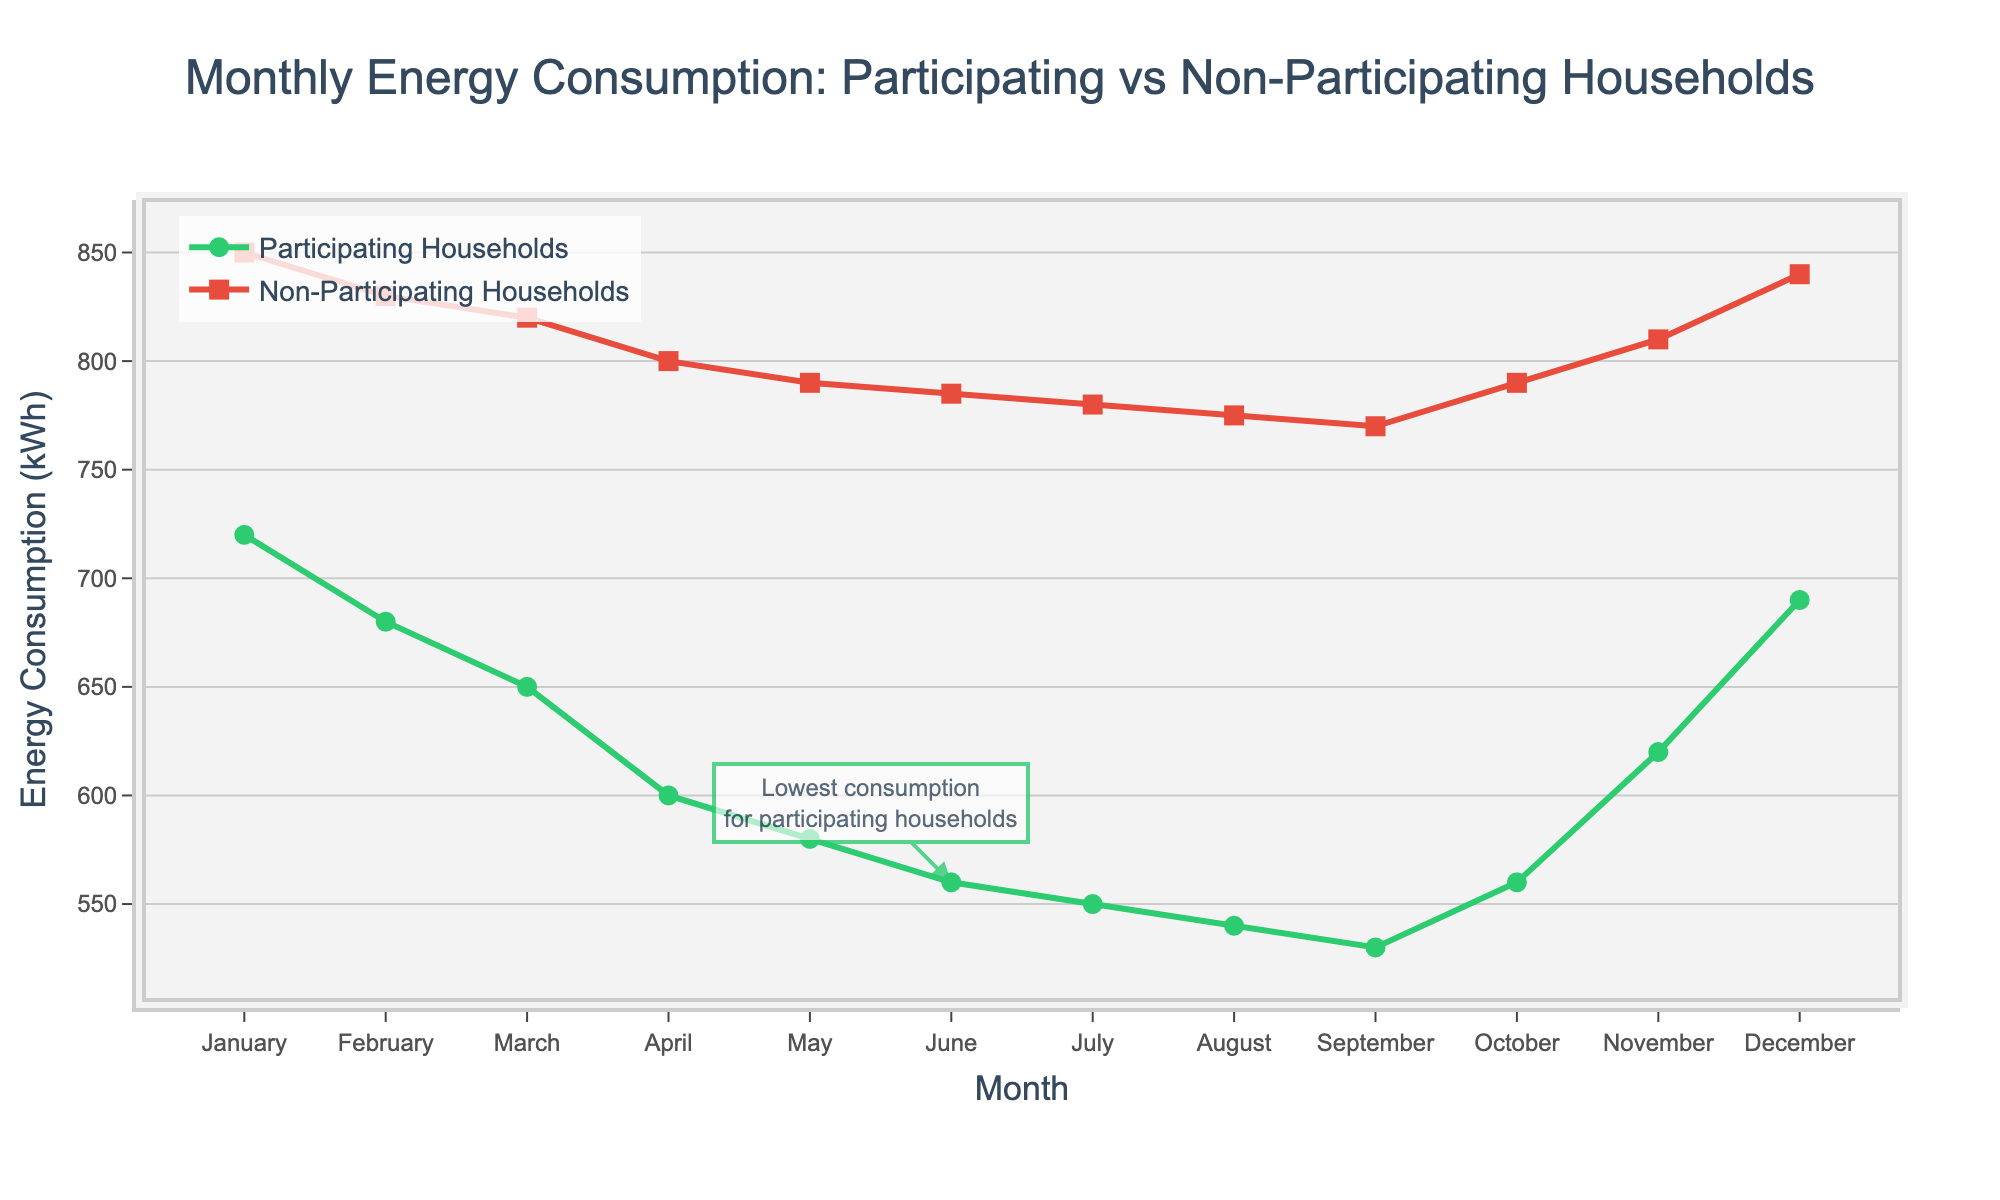What months have the lowest and highest energy consumption for participating households? The lowest energy consumption for participating households is in July, at 550 kWh, and the highest is in January, at 720 kWh.
Answer: July and January How much energy did non-participating households consume in April? According to the chart, non-participating households consumed 800 kWh in April.
Answer: 800 kWh What is the difference in energy consumption between participating and non-participating households in January? The energy consumption for participating households is 720 kWh and for non-participating households is 850 kWh in January. The difference is 850 - 720 = 130 kWh.
Answer: 130 kWh Which month shows the smallest difference in energy consumption between participating and non-participating households? In June, the energy consumption for participating households is 560 kWh and for non-participating households is 785 kWh, resulting in a difference of 225 kWh, which is the smallest difference among all months.
Answer: June Is there any month where energy consumption of participating households is more than non-participating households? Examining all the months, the energy consumption of participating households is always less than that of non-participating households.
Answer: No Between which consecutive months do participating households see the largest reduction in energy consumption? Comparing the reductions between each consecutive month, the largest reduction occurs from March (650 kWh) to April (600 kWh), with a difference of 50 kWh.
Answer: March to April What is the average energy consumption for non-participating households across the whole year? Adding all the monthly values for non-participating households: 850 + 830 + 820 + 800 + 790 + 785 + 780 + 775 + 770 + 790 + 810 + 840 = 9530 kWh. There are 12 months, so the average consumption is 9530 / 12 ≈ 794.17 kWh.
Answer: 794.17 kWh Identify the month where participating households have the most significant increase in energy consumption compared to the previous month. Analyzing the increases between consecutive months: October (560 kWh) to November (620 kWh) has the largest increase of 60 kWh among participating households.
Answer: November 